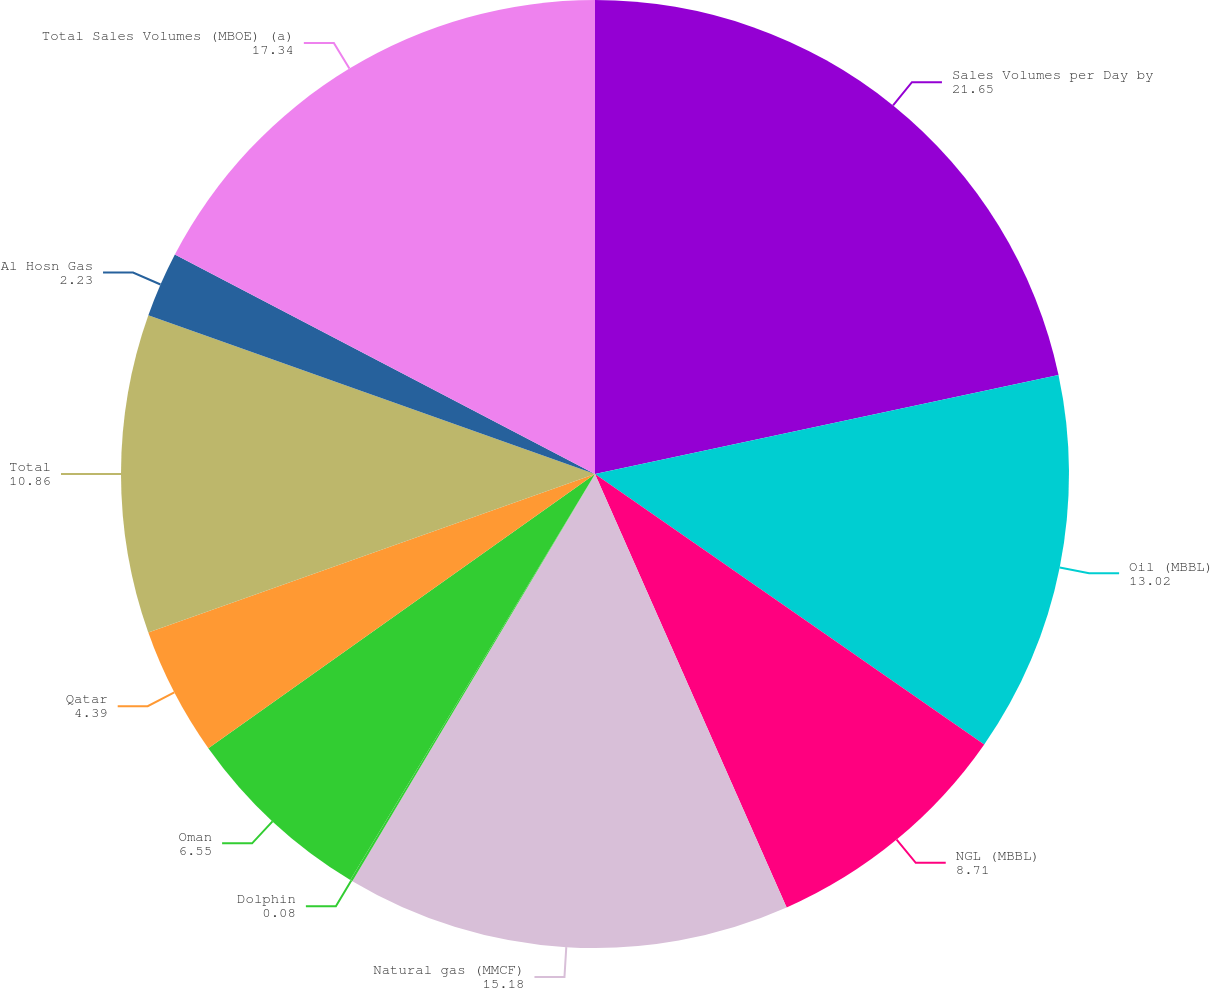Convert chart. <chart><loc_0><loc_0><loc_500><loc_500><pie_chart><fcel>Sales Volumes per Day by<fcel>Oil (MBBL)<fcel>NGL (MBBL)<fcel>Natural gas (MMCF)<fcel>Dolphin<fcel>Oman<fcel>Qatar<fcel>Total<fcel>Al Hosn Gas<fcel>Total Sales Volumes (MBOE) (a)<nl><fcel>21.65%<fcel>13.02%<fcel>8.71%<fcel>15.18%<fcel>0.08%<fcel>6.55%<fcel>4.39%<fcel>10.86%<fcel>2.23%<fcel>17.34%<nl></chart> 